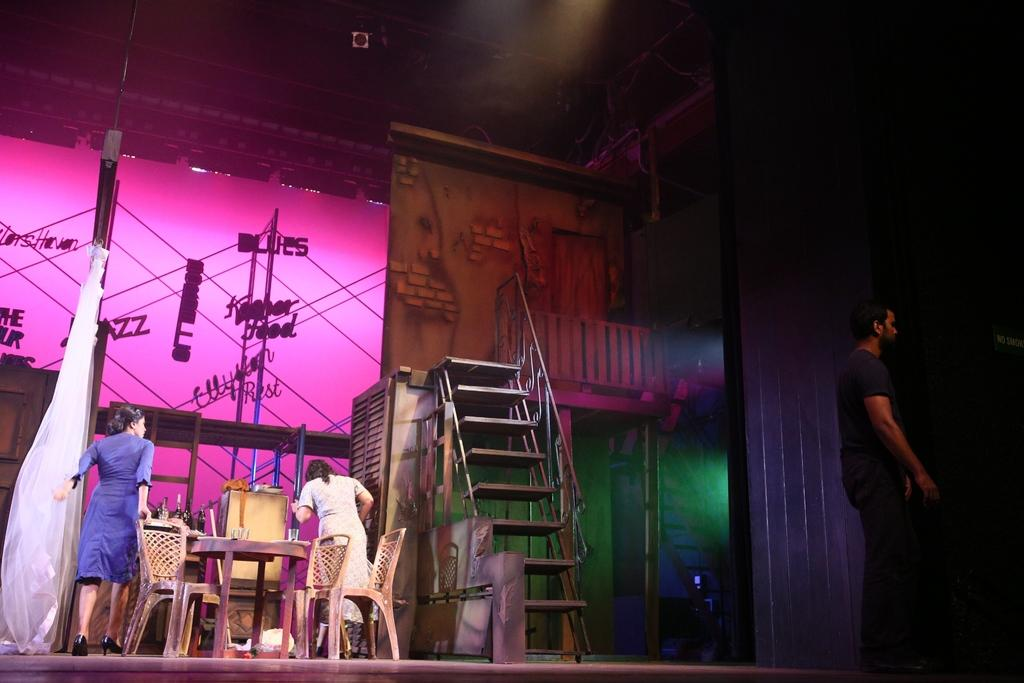What can be seen in the image regarding people? There are women standing in the image, as well as a man standing. What type of furniture is present in the image? There is a table and a chair in the image. What objects are on the table? There are glasses on the table. What architectural feature is visible in the image? There is a stair in the image. What type of arithmetic problem is being solved on the table? There is no arithmetic problem visible on the table in the image. What type of iron is present in the image? There is no iron present in the image. 